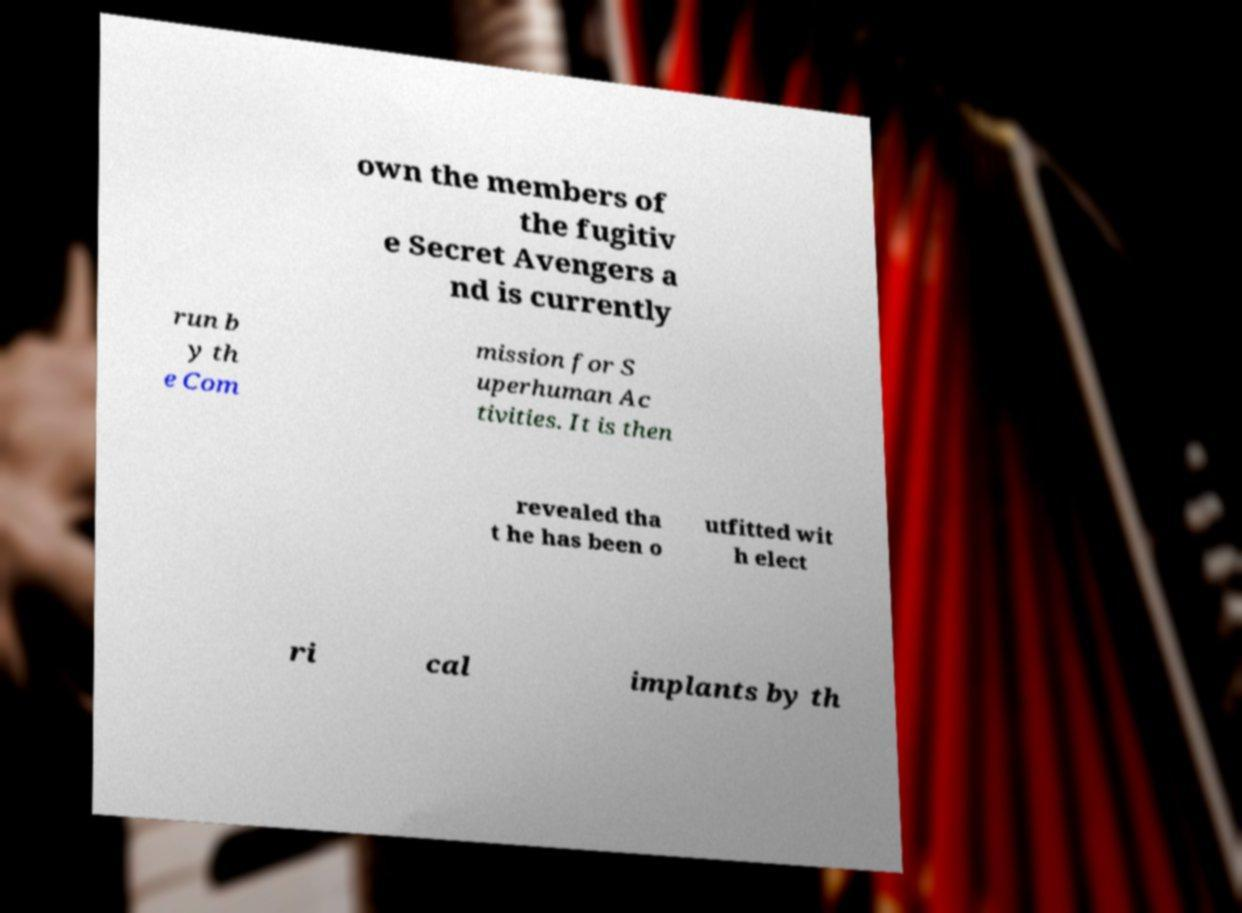Could you extract and type out the text from this image? own the members of the fugitiv e Secret Avengers a nd is currently run b y th e Com mission for S uperhuman Ac tivities. It is then revealed tha t he has been o utfitted wit h elect ri cal implants by th 